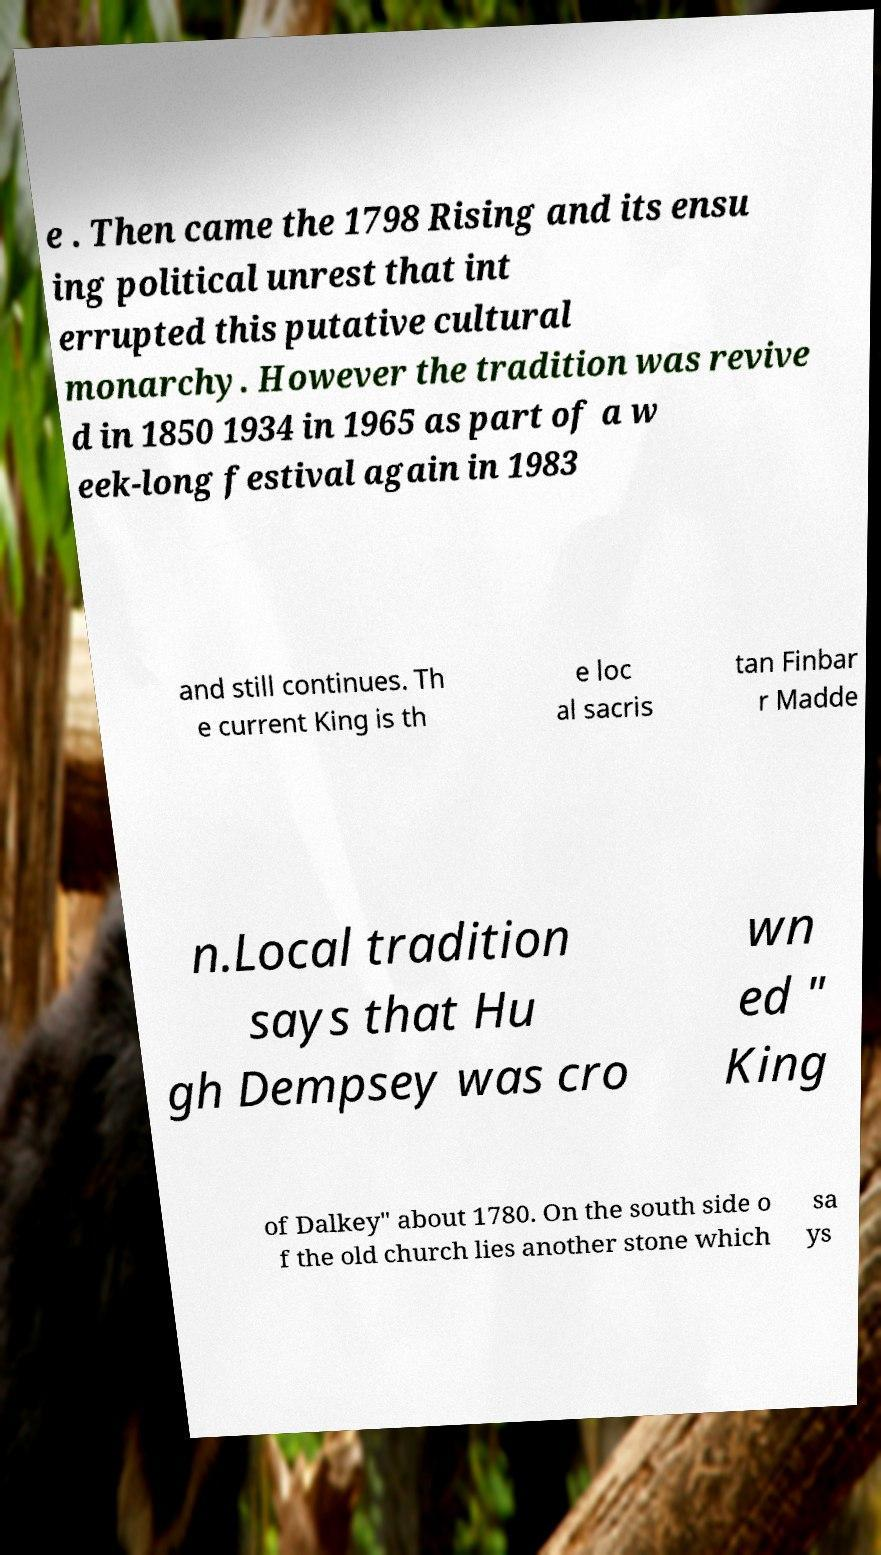For documentation purposes, I need the text within this image transcribed. Could you provide that? e . Then came the 1798 Rising and its ensu ing political unrest that int errupted this putative cultural monarchy. However the tradition was revive d in 1850 1934 in 1965 as part of a w eek-long festival again in 1983 and still continues. Th e current King is th e loc al sacris tan Finbar r Madde n.Local tradition says that Hu gh Dempsey was cro wn ed " King of Dalkey" about 1780. On the south side o f the old church lies another stone which sa ys 